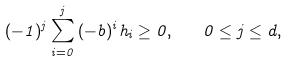<formula> <loc_0><loc_0><loc_500><loc_500>( - 1 ) ^ { j } \sum _ { i = 0 } ^ { j } { ( - b ) ^ { i } h _ { i } } \geq 0 , \quad 0 \leq j \leq d ,</formula> 